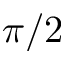<formula> <loc_0><loc_0><loc_500><loc_500>\pi / 2</formula> 